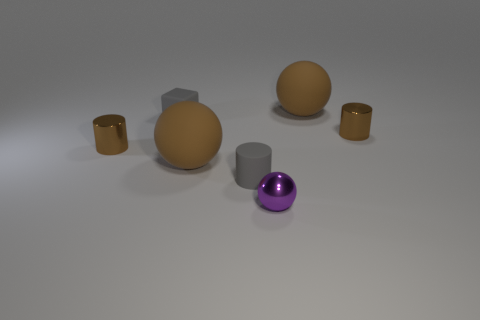Do the block and the purple object have the same material?
Give a very brief answer. No. The metallic object that is right of the tiny purple ball has what shape?
Ensure brevity in your answer.  Cylinder. There is a tiny metal cylinder that is on the left side of the purple object; are there any purple objects to the left of it?
Your response must be concise. No. Is there another gray rubber block of the same size as the block?
Your answer should be very brief. No. Does the cylinder that is right of the small ball have the same color as the matte cube?
Keep it short and to the point. No. What is the size of the purple object?
Your response must be concise. Small. What size is the gray object that is left of the large brown matte thing in front of the small gray cube?
Provide a succinct answer. Small. How many large rubber spheres are the same color as the rubber cube?
Ensure brevity in your answer.  0. How many big matte objects are there?
Your response must be concise. 2. How many spheres have the same material as the gray block?
Your answer should be very brief. 2. 